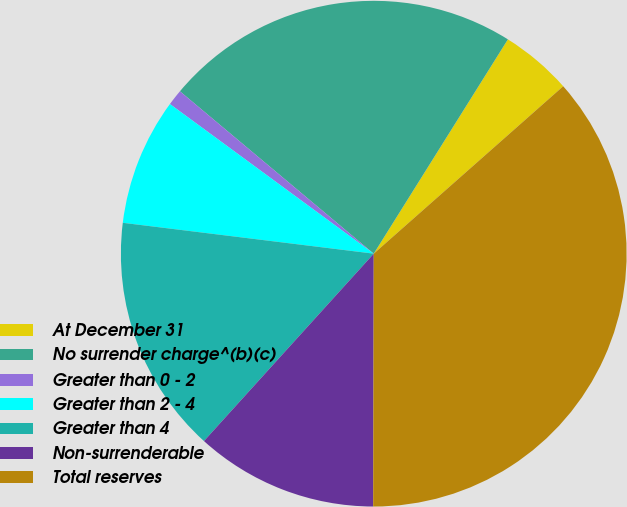Convert chart to OTSL. <chart><loc_0><loc_0><loc_500><loc_500><pie_chart><fcel>At December 31<fcel>No surrender charge^(b)(c)<fcel>Greater than 0 - 2<fcel>Greater than 2 - 4<fcel>Greater than 4<fcel>Non-surrenderable<fcel>Total reserves<nl><fcel>4.58%<fcel>22.8%<fcel>1.02%<fcel>8.13%<fcel>15.23%<fcel>11.68%<fcel>36.55%<nl></chart> 